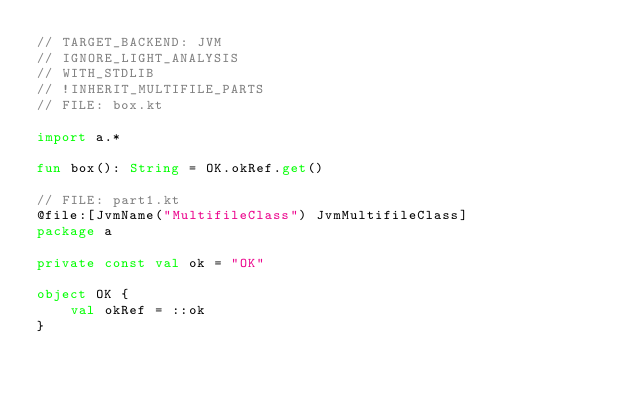<code> <loc_0><loc_0><loc_500><loc_500><_Kotlin_>// TARGET_BACKEND: JVM
// IGNORE_LIGHT_ANALYSIS
// WITH_STDLIB
// !INHERIT_MULTIFILE_PARTS
// FILE: box.kt

import a.*

fun box(): String = OK.okRef.get()

// FILE: part1.kt
@file:[JvmName("MultifileClass") JvmMultifileClass]
package a

private const val ok = "OK"

object OK {
    val okRef = ::ok
}
</code> 